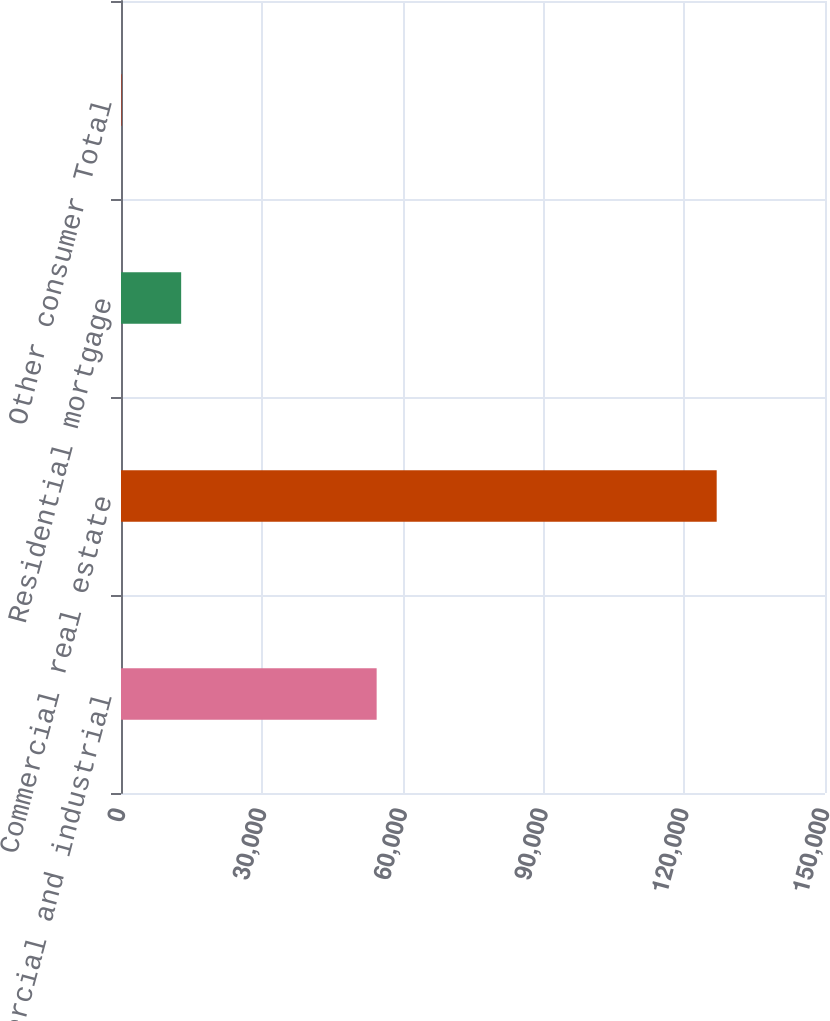Convert chart. <chart><loc_0><loc_0><loc_500><loc_500><bar_chart><fcel>Commercial and industrial<fcel>Commercial real estate<fcel>Residential mortgage<fcel>Other consumer Total<nl><fcel>54472<fcel>126923<fcel>12818.3<fcel>140<nl></chart> 